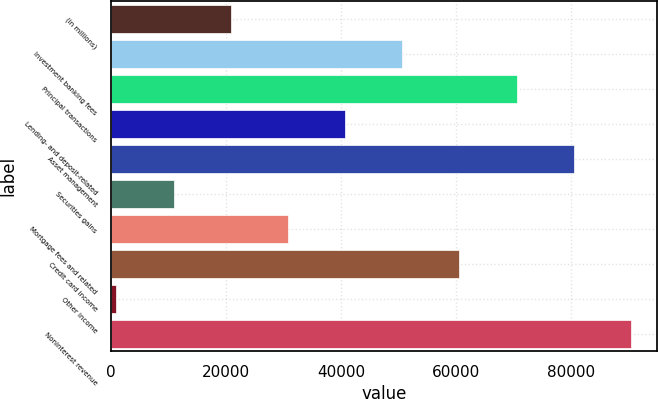Convert chart. <chart><loc_0><loc_0><loc_500><loc_500><bar_chart><fcel>(in millions)<fcel>Investment banking fees<fcel>Principal transactions<fcel>Lending- and deposit-related<fcel>Asset management<fcel>Securities gains<fcel>Mortgage fees and related<fcel>Credit card income<fcel>Other income<fcel>Noninterest revenue<nl><fcel>20819.6<fcel>50675<fcel>70578.6<fcel>40723.2<fcel>80530.4<fcel>10867.8<fcel>30771.4<fcel>60626.8<fcel>916<fcel>90482.2<nl></chart> 